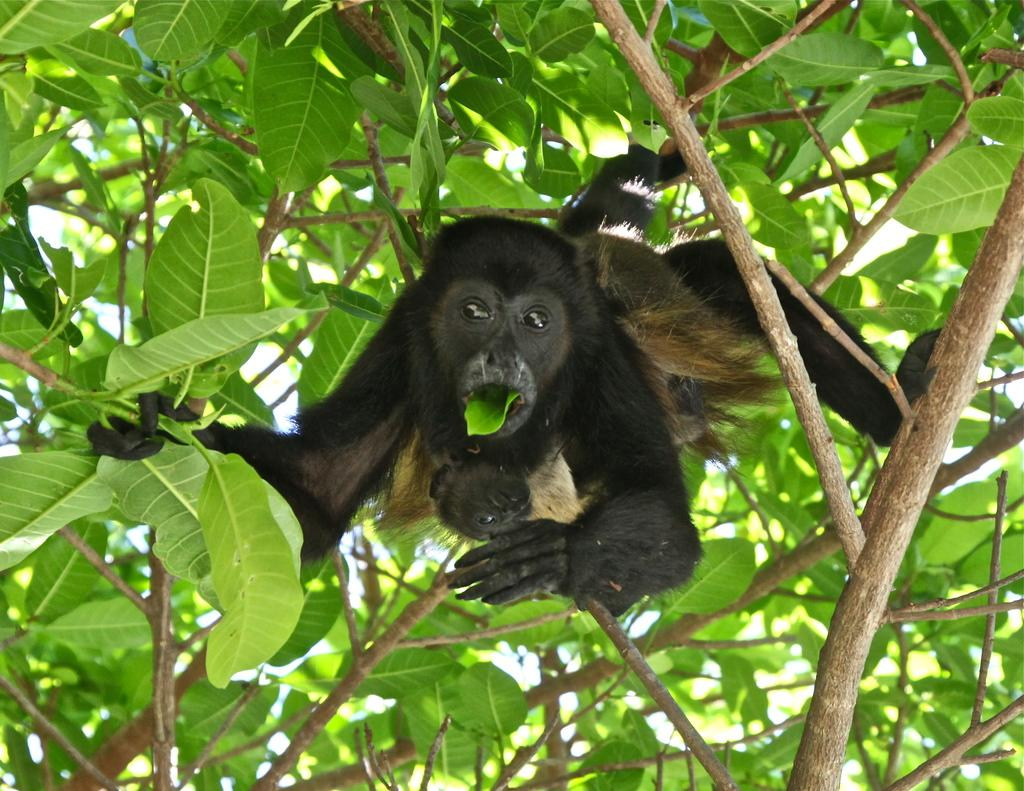What animal is present in the image? There is a chimpanzee in the image. What is the chimpanzee doing in the image? The chimpanzee is on tree stems and eating a leaf. What can be seen in the background of the image? There are leaves and tree stems visible in the image. What type of fiction is the chimpanzee reading while sitting on the chair in the image? There is no fiction or chair present in the image; it features a chimpanzee on tree stems eating a leaf. Can you tell me the color of the tiger in the image? There is no tiger present in the image; it features a chimpanzee on tree stems eating a leaf. 